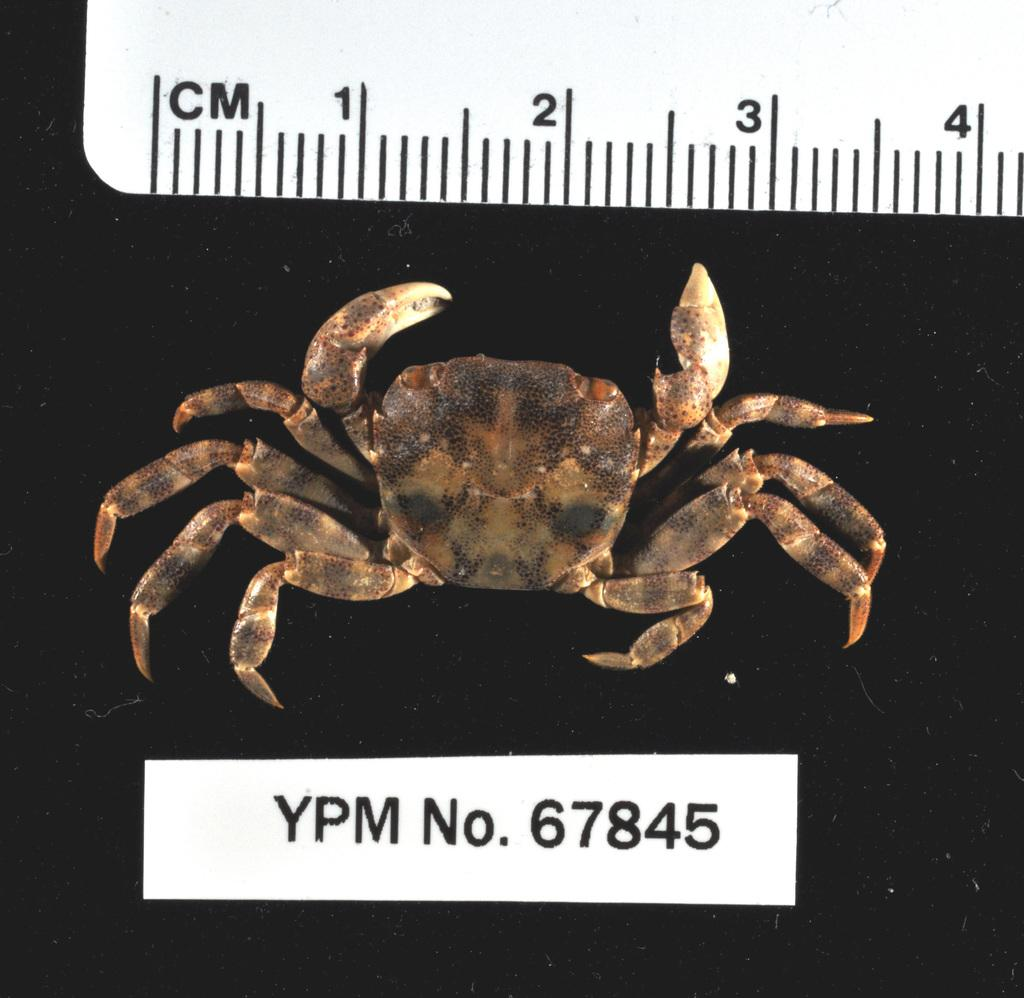What type of animal is in the image? There is a crab in the image. What object is used for measuring in the image? There is a scale with measurements in the image. Is there any text present in the image? Yes, there is some text at the bottom of the image. What type of fuel is being used by the crab in the image? There is no fuel present in the image, as it features a crab and a scale with measurements. 